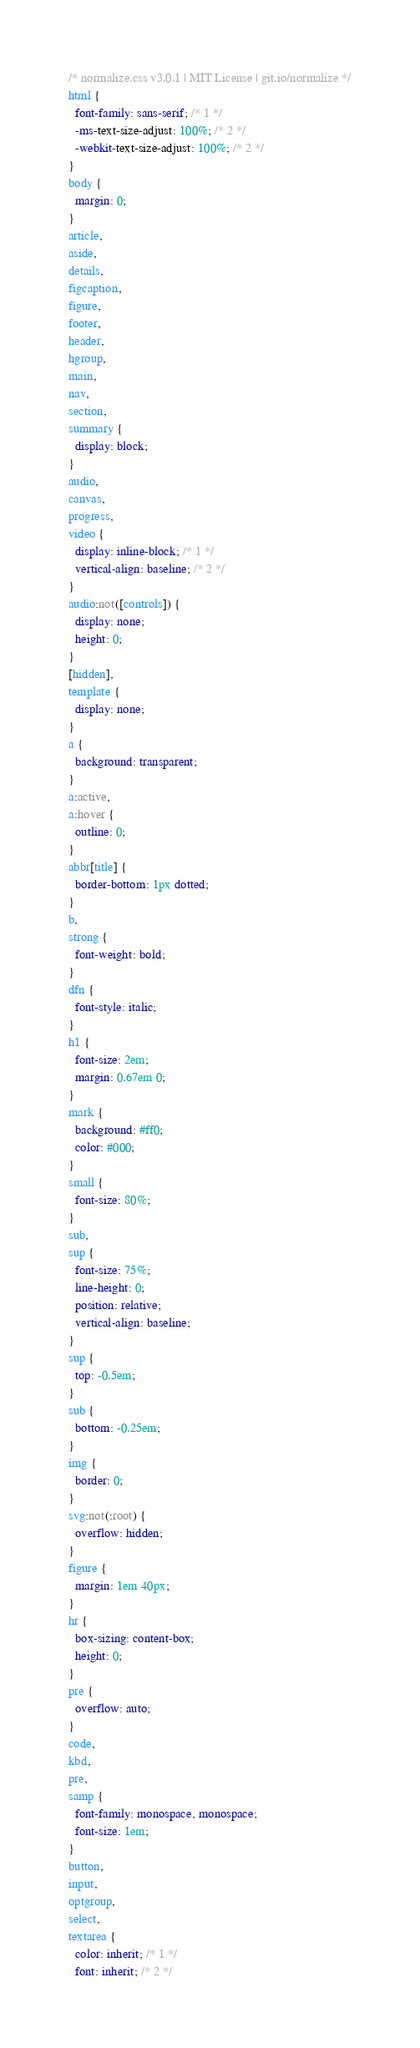<code> <loc_0><loc_0><loc_500><loc_500><_CSS_>/* normalize.css v3.0.1 | MIT License | git.io/normalize */
html {
  font-family: sans-serif; /* 1 */
  -ms-text-size-adjust: 100%; /* 2 */
  -webkit-text-size-adjust: 100%; /* 2 */
}
body {
  margin: 0;
}
article,
aside,
details,
figcaption,
figure,
footer,
header,
hgroup,
main,
nav,
section,
summary {
  display: block;
}
audio,
canvas,
progress,
video {
  display: inline-block; /* 1 */
  vertical-align: baseline; /* 2 */
}
audio:not([controls]) {
  display: none;
  height: 0;
}
[hidden],
template {
  display: none;
}
a {
  background: transparent;
}
a:active,
a:hover {
  outline: 0;
}
abbr[title] {
  border-bottom: 1px dotted;
}
b,
strong {
  font-weight: bold;
}
dfn {
  font-style: italic;
}
h1 {
  font-size: 2em;
  margin: 0.67em 0;
}
mark {
  background: #ff0;
  color: #000;
}
small {
  font-size: 80%;
}
sub,
sup {
  font-size: 75%;
  line-height: 0;
  position: relative;
  vertical-align: baseline;
}
sup {
  top: -0.5em;
}
sub {
  bottom: -0.25em;
}
img {
  border: 0;
}
svg:not(:root) {
  overflow: hidden;
}
figure {
  margin: 1em 40px;
}
hr {
  box-sizing: content-box;
  height: 0;
}
pre {
  overflow: auto;
}
code,
kbd,
pre,
samp {
  font-family: monospace, monospace;
  font-size: 1em;
}
button,
input,
optgroup,
select,
textarea {
  color: inherit; /* 1 */
  font: inherit; /* 2 */</code> 